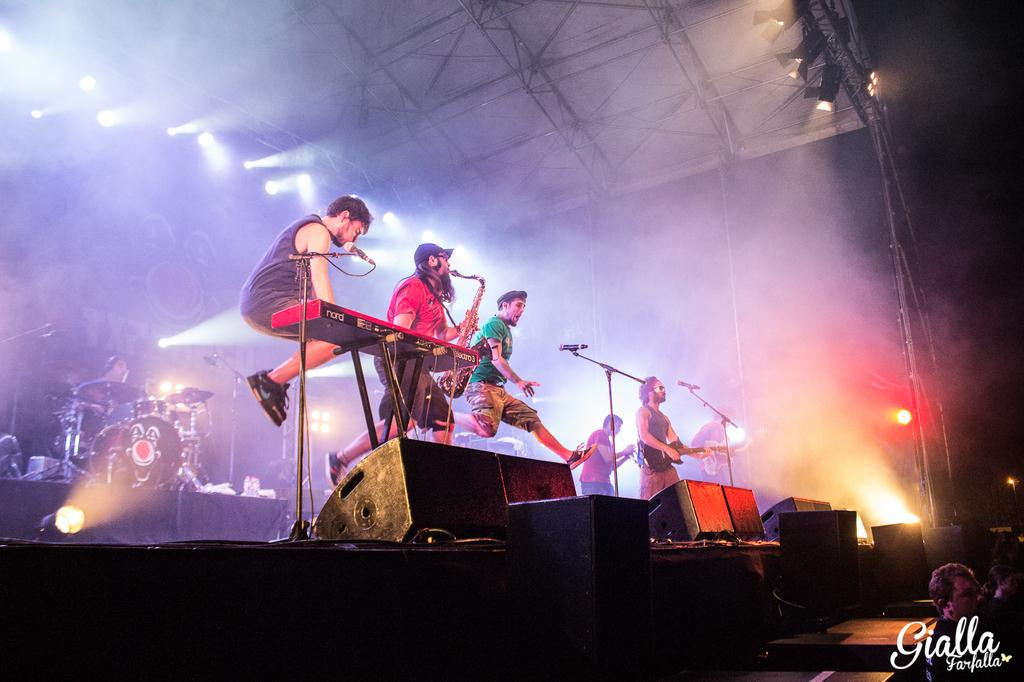How many people are in the image? There are persons in the image. What are the persons doing in the image? The persons are holding musical instruments. What equipment is present in front of the persons? There are microphones in front of the persons. Can you see a rat playing with a blade in the image? There is no rat or blade present in the image. 